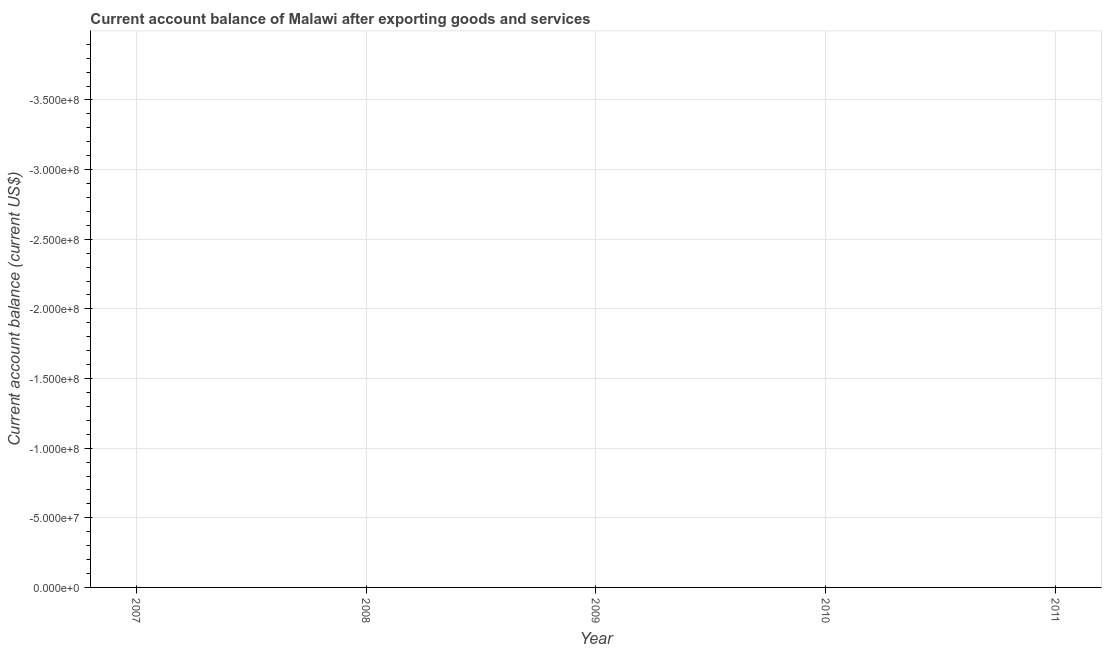What is the current account balance in 2011?
Provide a succinct answer. 0. In how many years, is the current account balance greater than the average current account balance taken over all years?
Offer a very short reply. 0. How many years are there in the graph?
Your response must be concise. 5. Does the graph contain any zero values?
Give a very brief answer. Yes. Does the graph contain grids?
Give a very brief answer. Yes. What is the title of the graph?
Offer a very short reply. Current account balance of Malawi after exporting goods and services. What is the label or title of the X-axis?
Your answer should be compact. Year. What is the label or title of the Y-axis?
Offer a very short reply. Current account balance (current US$). What is the Current account balance (current US$) in 2009?
Offer a terse response. 0. 